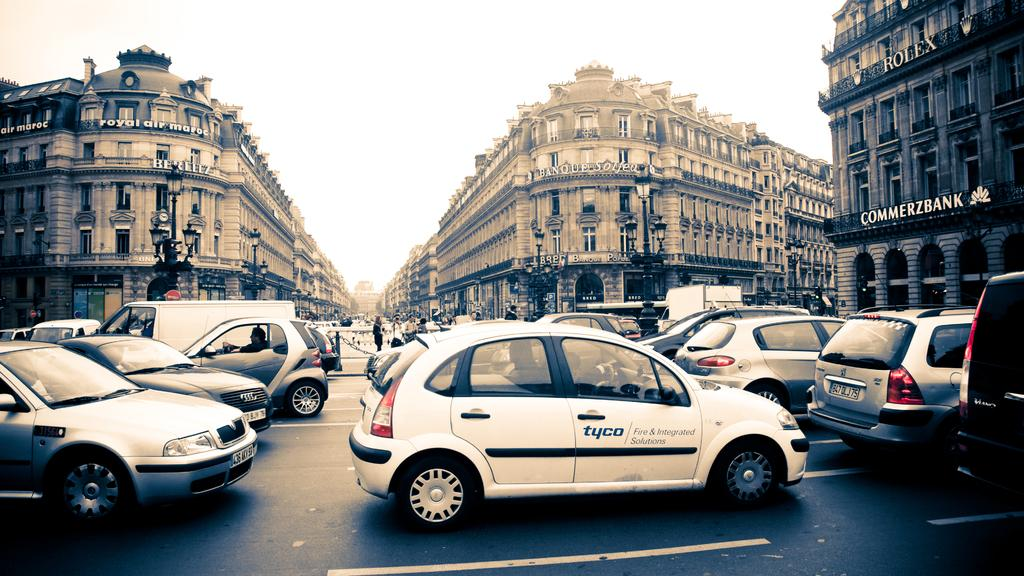<image>
Render a clear and concise summary of the photo. A car with tyco on it amoung other cars are on the street with buildings around, including one with ROLEX and COMMERZBANK on it. 